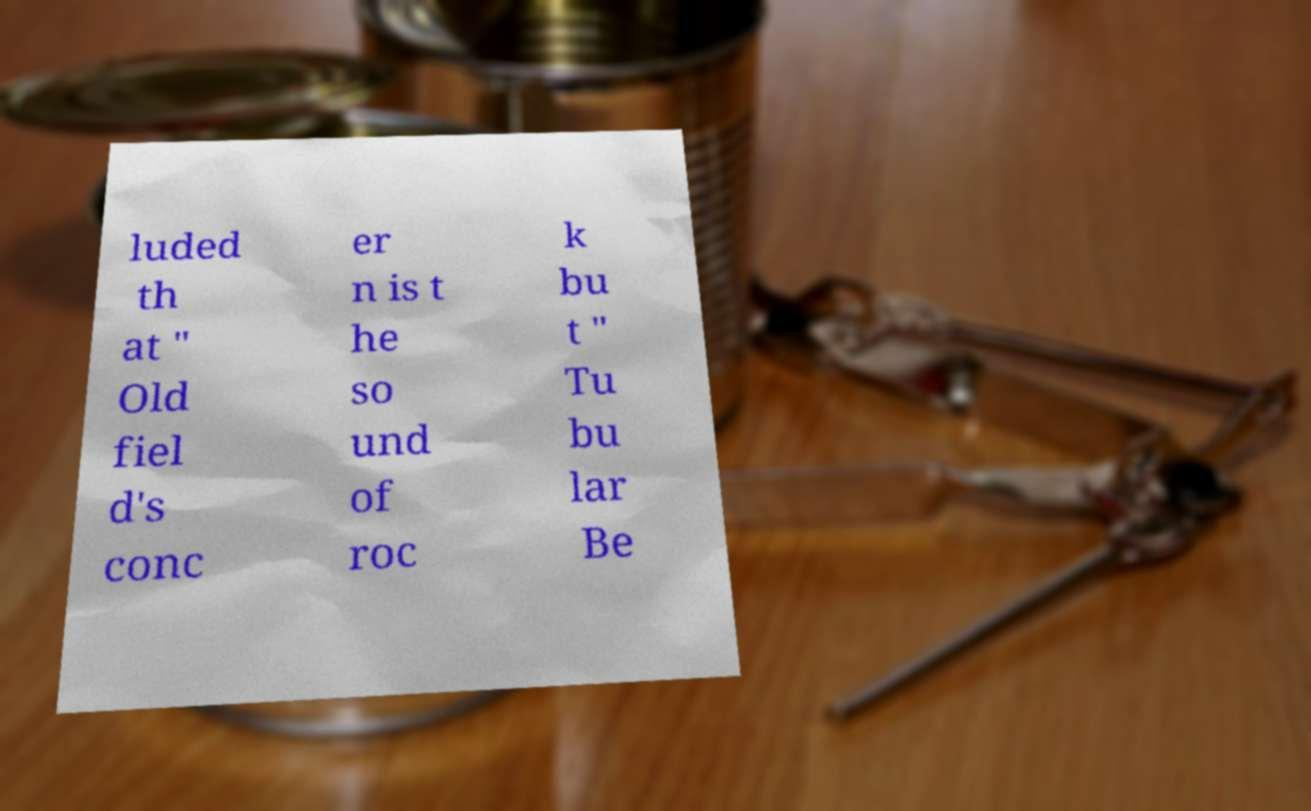Can you read and provide the text displayed in the image?This photo seems to have some interesting text. Can you extract and type it out for me? luded th at " Old fiel d's conc er n is t he so und of roc k bu t " Tu bu lar Be 